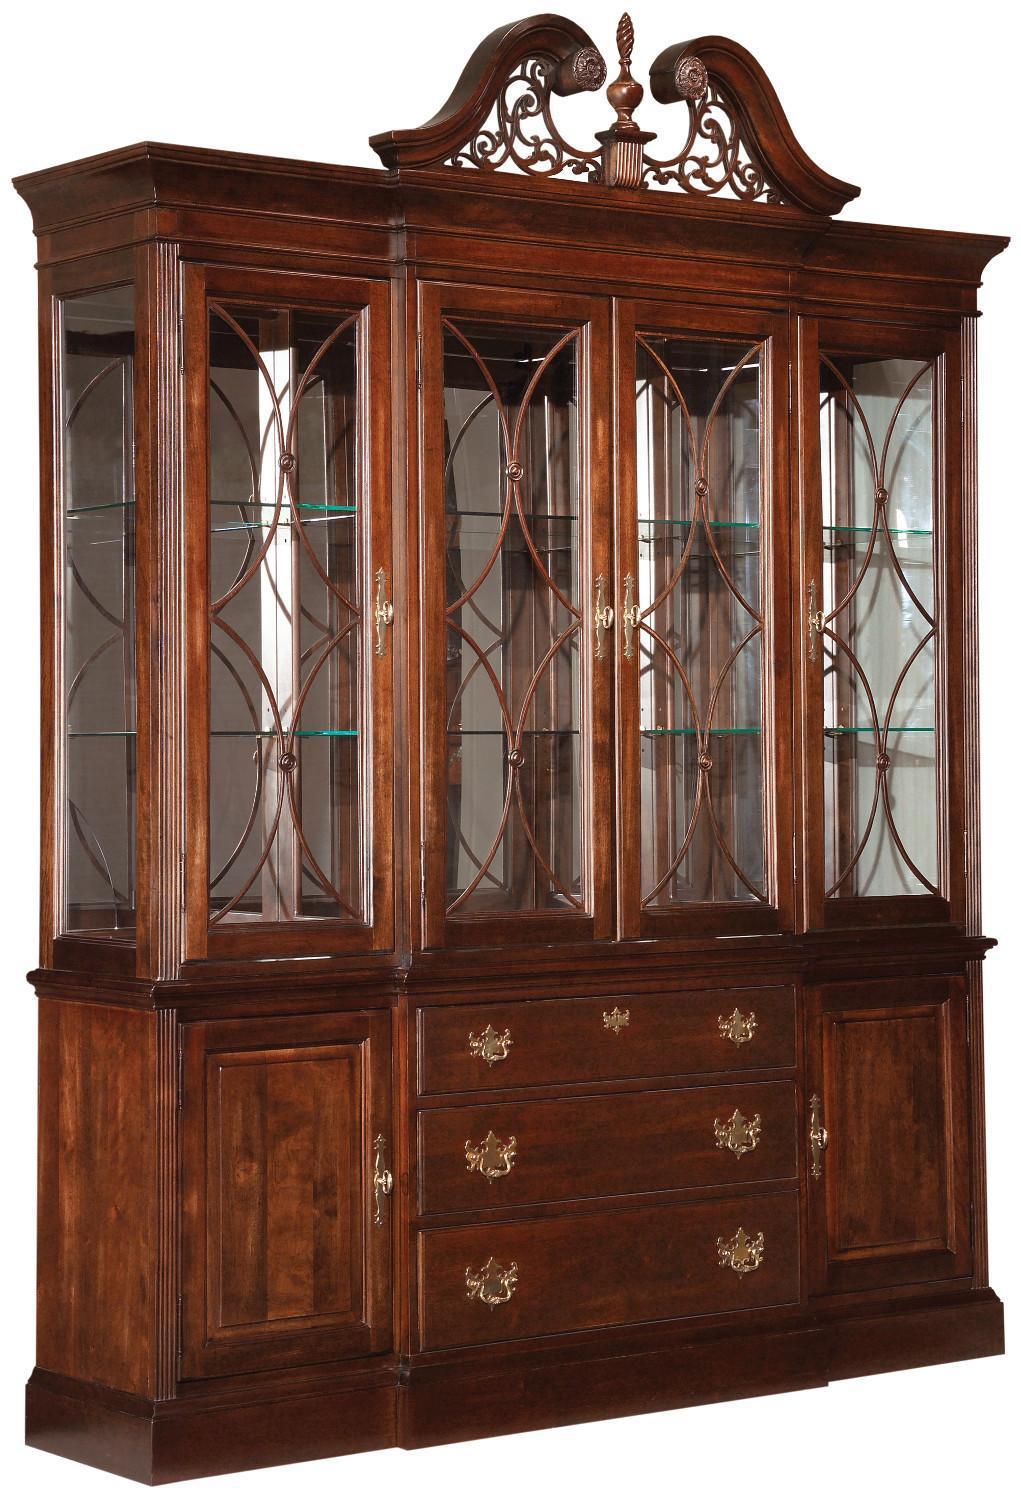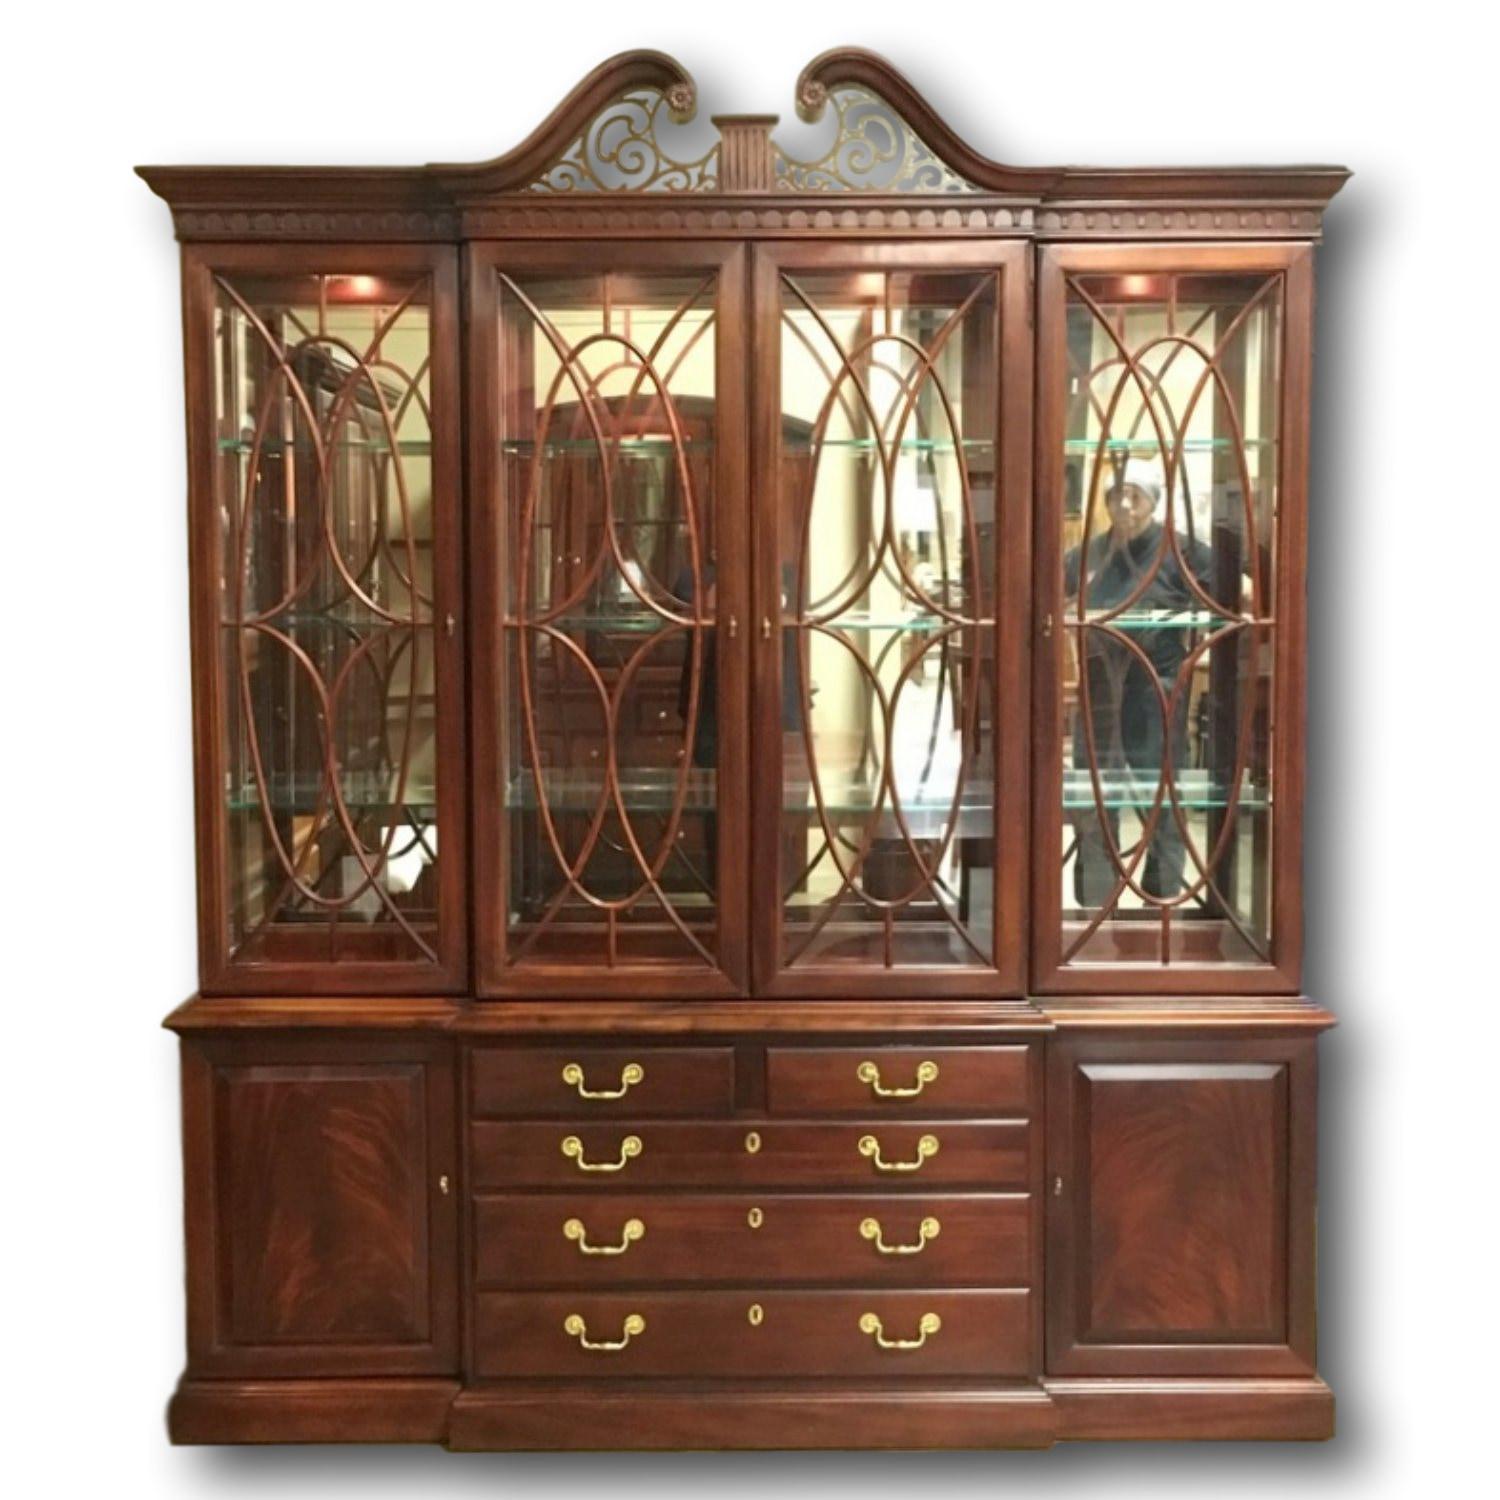The first image is the image on the left, the second image is the image on the right. For the images shown, is this caption "The shelves on the left are full." true? Answer yes or no. No. 